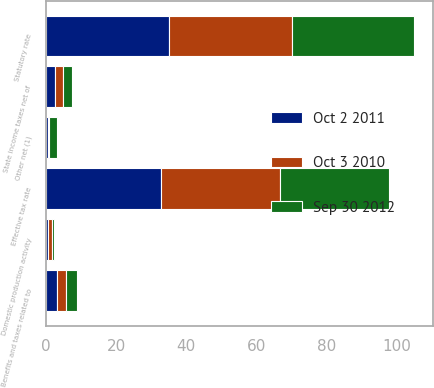Convert chart. <chart><loc_0><loc_0><loc_500><loc_500><stacked_bar_chart><ecel><fcel>Statutory rate<fcel>State income taxes net of<fcel>Benefits and taxes related to<fcel>Domestic production activity<fcel>Other net (1)<fcel>Effective tax rate<nl><fcel>Oct 2 2011<fcel>35<fcel>2.5<fcel>3.3<fcel>0.7<fcel>0.7<fcel>32.8<nl><fcel>Sep 30 2012<fcel>35<fcel>2.5<fcel>3.1<fcel>0.8<fcel>2.5<fcel>31.1<nl><fcel>Oct 3 2010<fcel>35<fcel>2.5<fcel>2.5<fcel>0.9<fcel>0.1<fcel>34<nl></chart> 